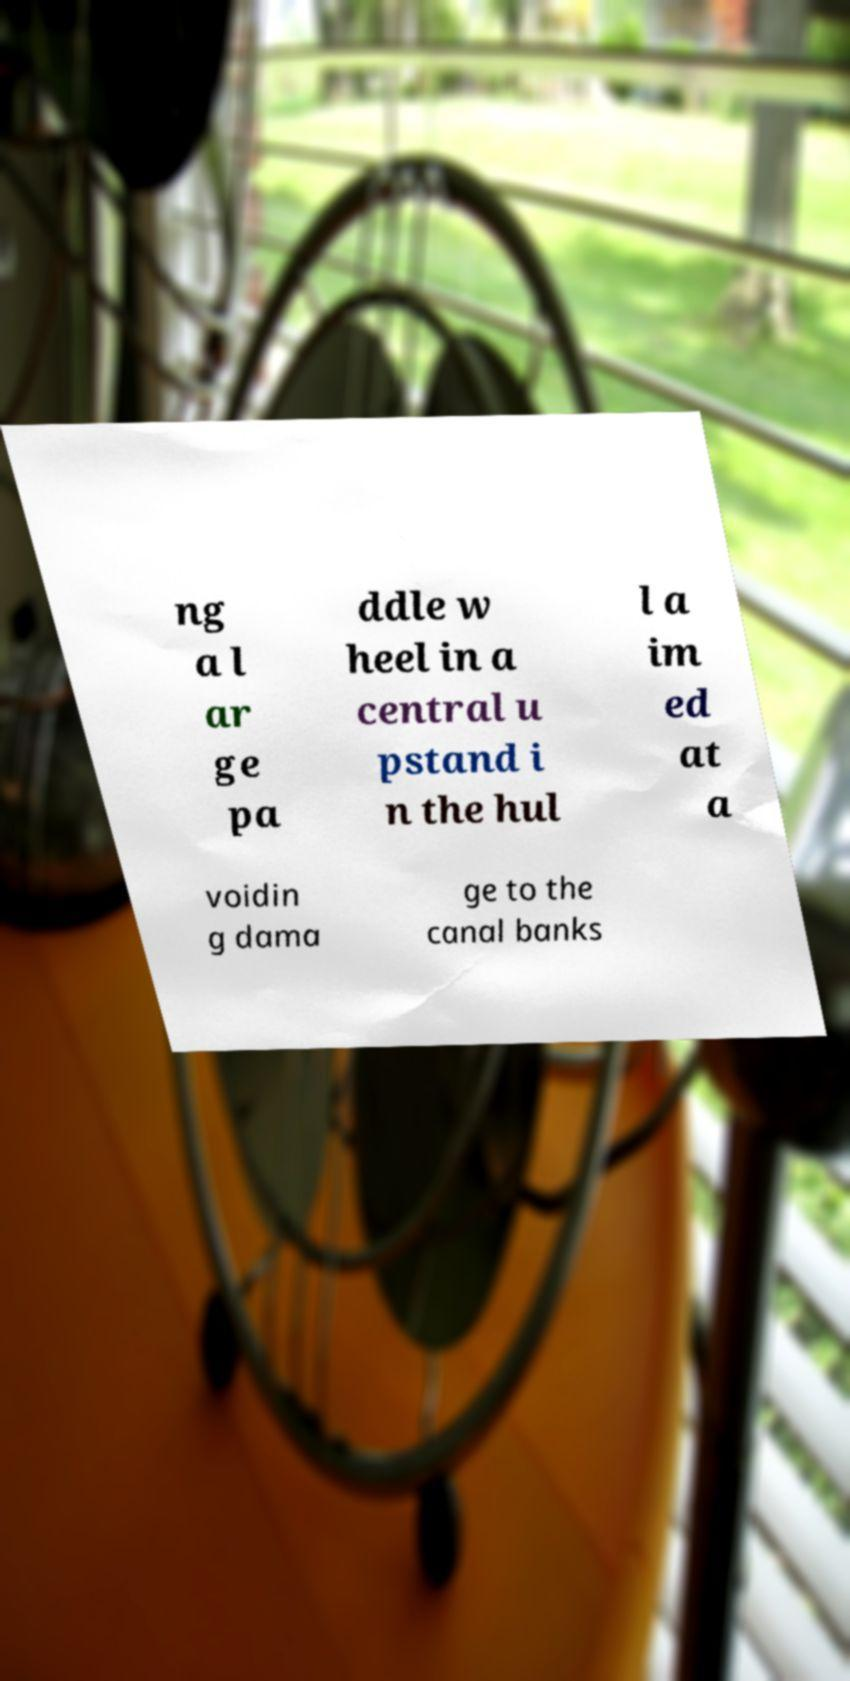What messages or text are displayed in this image? I need them in a readable, typed format. ng a l ar ge pa ddle w heel in a central u pstand i n the hul l a im ed at a voidin g dama ge to the canal banks 